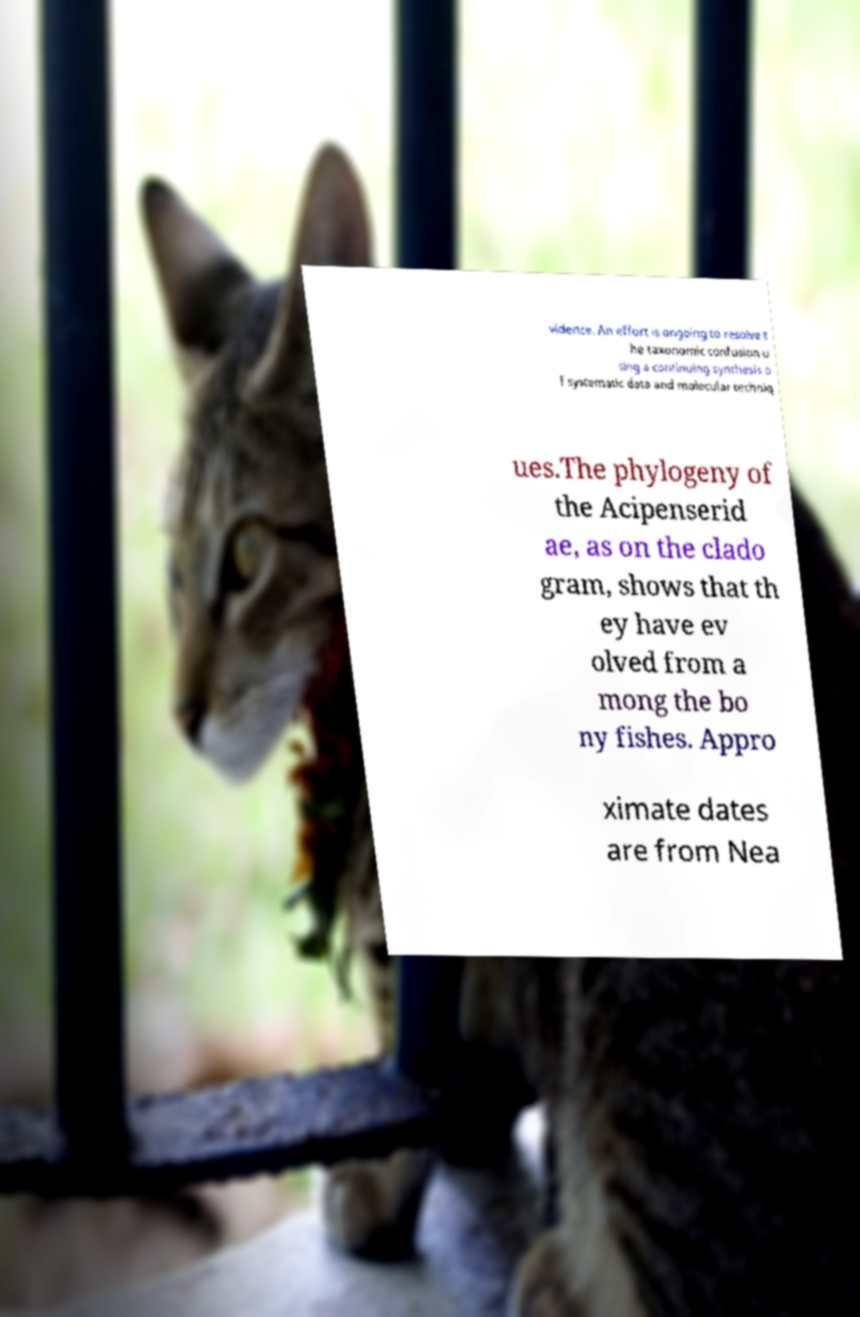Please identify and transcribe the text found in this image. vidence. An effort is ongoing to resolve t he taxonomic confusion u sing a continuing synthesis o f systematic data and molecular techniq ues.The phylogeny of the Acipenserid ae, as on the clado gram, shows that th ey have ev olved from a mong the bo ny fishes. Appro ximate dates are from Nea 